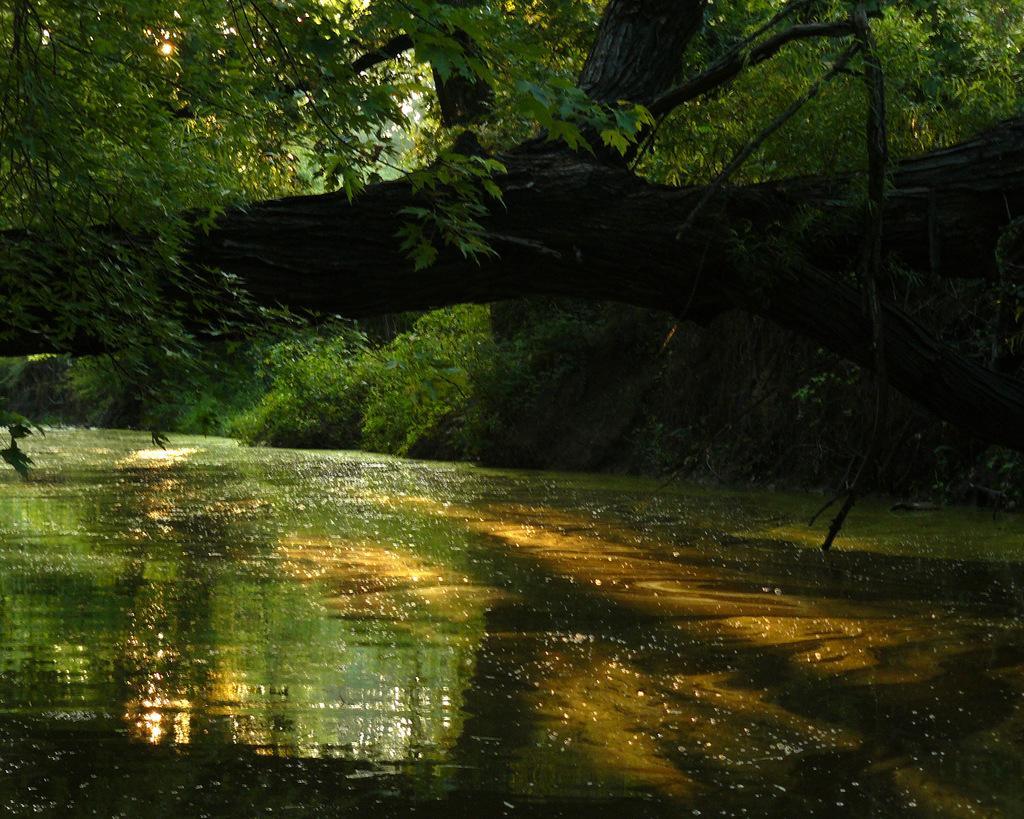How would you summarize this image in a sentence or two? This image is taken outdoors. At the bottom of the image there is a lake with water. In the middle of the image there is a branch of a tree and there are many trees and plants. 